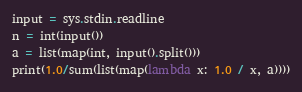Convert code to text. <code><loc_0><loc_0><loc_500><loc_500><_Python_>input = sys.stdin.readline
n = int(input())
a = list(map(int, input().split()))
print(1.0/sum(list(map(lambda x: 1.0 / x, a))))
</code> 